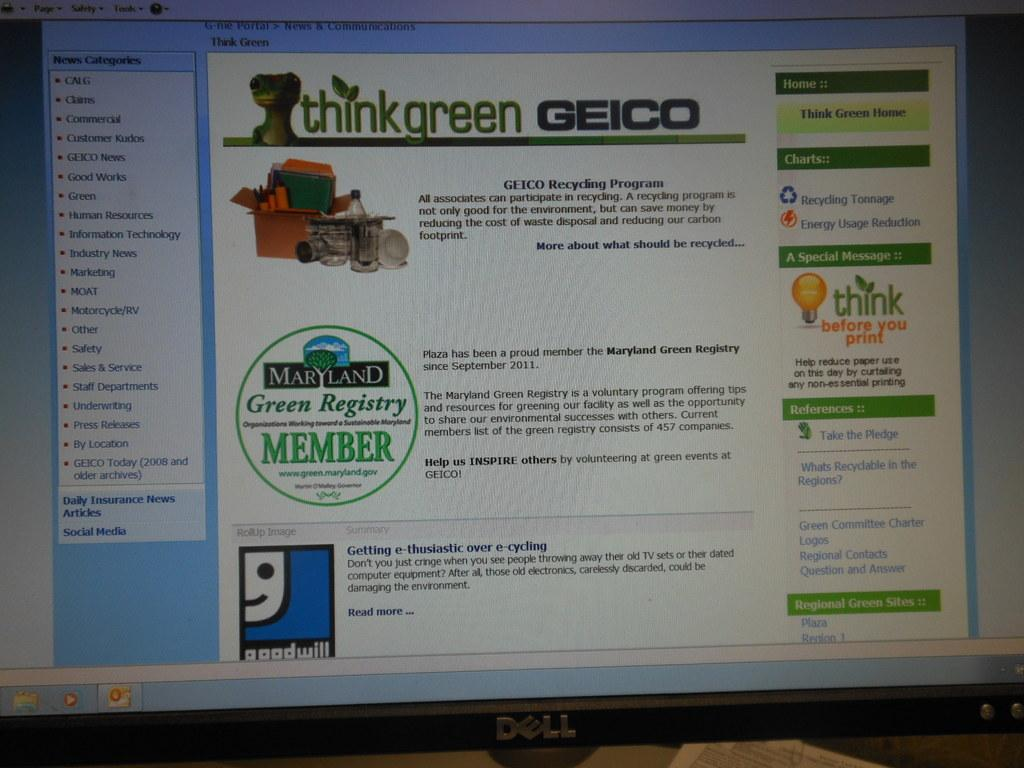<image>
Share a concise interpretation of the image provided. Dell computer screen showing a website for "ThinkGreen Geico". 